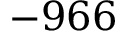Convert formula to latex. <formula><loc_0><loc_0><loc_500><loc_500>- 9 6 6</formula> 